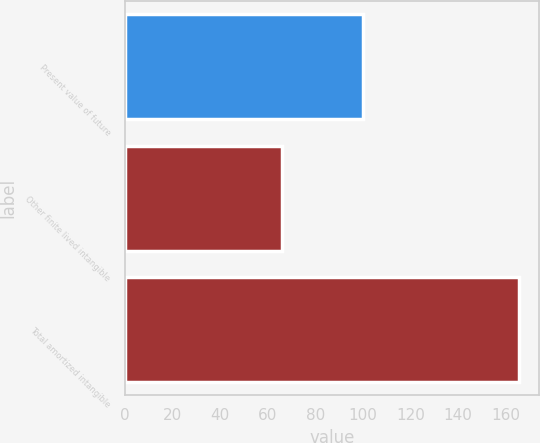Convert chart to OTSL. <chart><loc_0><loc_0><loc_500><loc_500><bar_chart><fcel>Present value of future<fcel>Other finite lived intangible<fcel>Total amortized intangible<nl><fcel>100<fcel>65.8<fcel>165.8<nl></chart> 